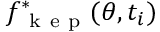Convert formula to latex. <formula><loc_0><loc_0><loc_500><loc_500>f _ { k e p } ^ { * } ( \theta , t _ { i } )</formula> 